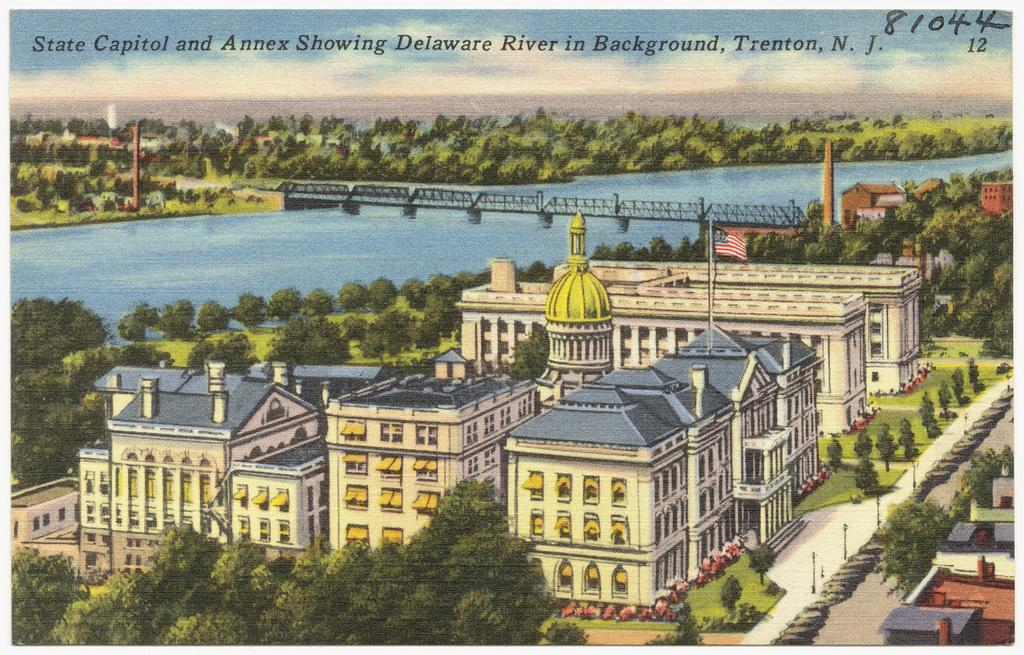<image>
Write a terse but informative summary of the picture. The drawing depicts the Delaware River in Trenton, New Jersey. 